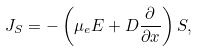Convert formula to latex. <formula><loc_0><loc_0><loc_500><loc_500>J _ { S } = - \left ( \mu _ { e } E + D \frac { \partial } { \partial x } \right ) S ,</formula> 